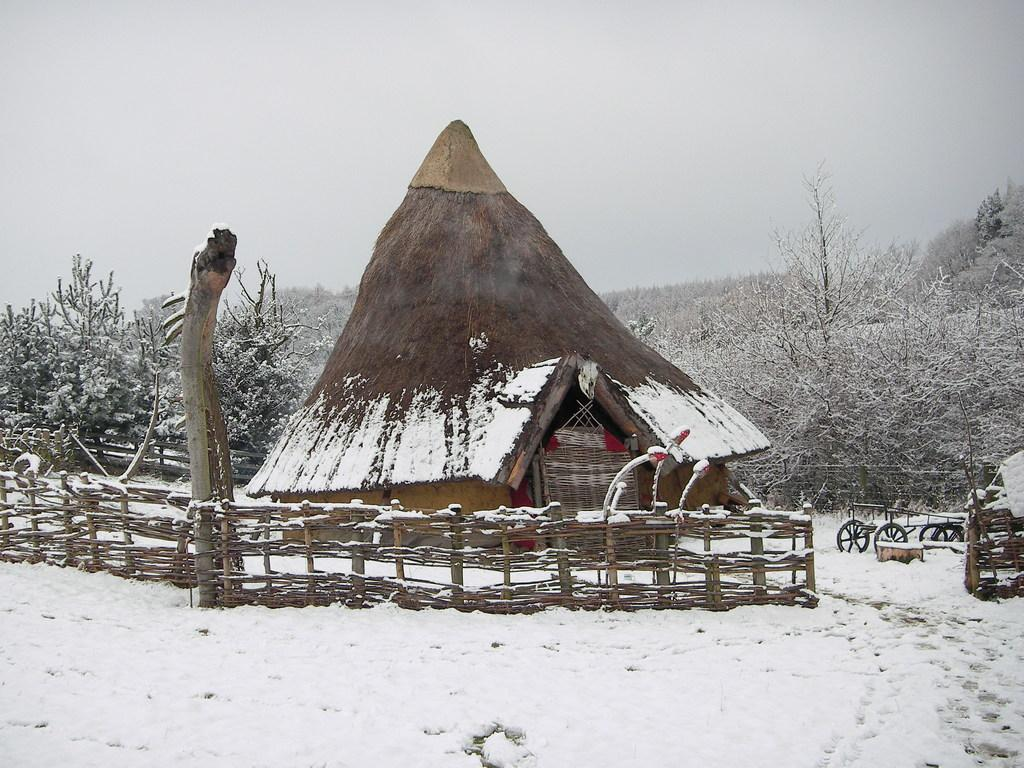What is the hot object in the image? The image contains a hot object, possibly a pot or stove. What type of barrier can be seen in the image? There is a fence in the image. What is the weather like in the image? Snow is present in the image, indicating a cold or snowy environment. What type of vehicle is in the image? There is a cart in the image. What type of vegetation is visible in the image? Trees covered with snow are visible in the image. What is visible in the background of the image? The sky is visible in the background of the image. What type of beast is pulling the cart in the image? There is no beast present in the image; it is a cart without any animals pulling it. How does the growth of the trees in the image contribute to the overall aesthetic? There is no mention of the growth of the trees in the image, as the focus is on the snow-covered trees. 